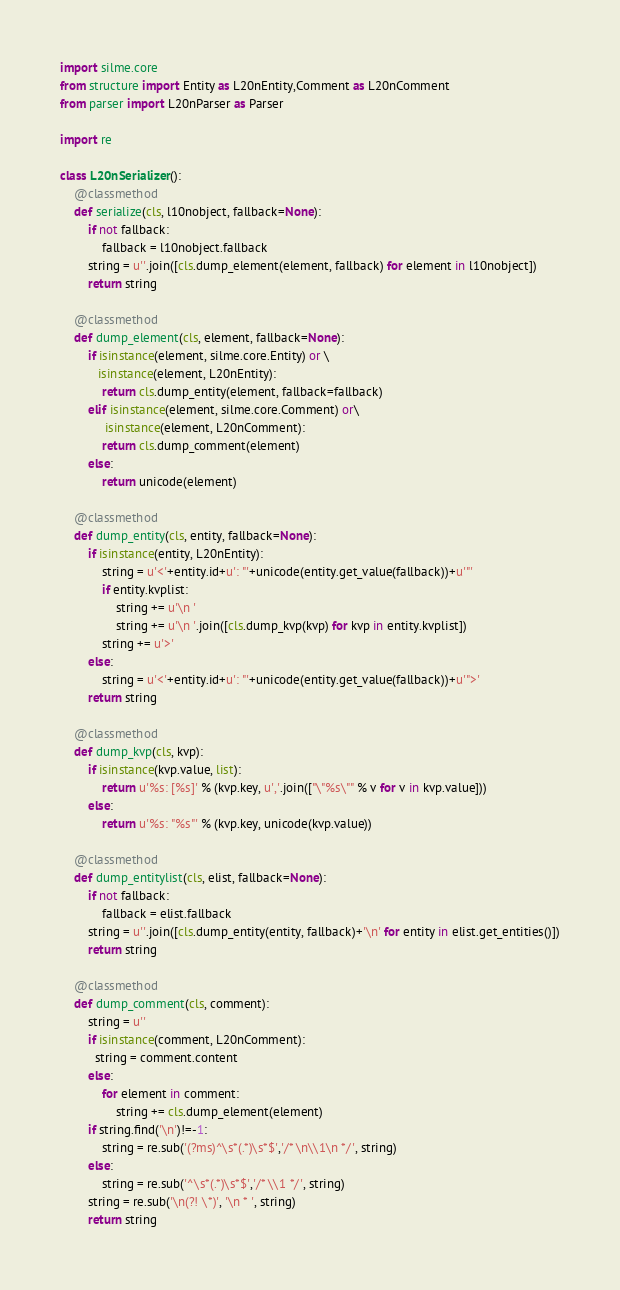<code> <loc_0><loc_0><loc_500><loc_500><_Python_>import silme.core
from structure import Entity as L20nEntity,Comment as L20nComment
from parser import L20nParser as Parser

import re

class L20nSerializer():
    @classmethod
    def serialize(cls, l10nobject, fallback=None):
        if not fallback:
            fallback = l10nobject.fallback
        string = u''.join([cls.dump_element(element, fallback) for element in l10nobject])
        return string

    @classmethod
    def dump_element(cls, element, fallback=None):
        if isinstance(element, silme.core.Entity) or \
           isinstance(element, L20nEntity):
            return cls.dump_entity(element, fallback=fallback)
        elif isinstance(element, silme.core.Comment) or\
             isinstance(element, L20nComment):
            return cls.dump_comment(element)
        else:
            return unicode(element)

    @classmethod
    def dump_entity(cls, entity, fallback=None):
        if isinstance(entity, L20nEntity):
            string = u'<'+entity.id+u': "'+unicode(entity.get_value(fallback))+u'"'
            if entity.kvplist:
                string += u'\n '
                string += u'\n '.join([cls.dump_kvp(kvp) for kvp in entity.kvplist])
            string += u'>'
        else:
            string = u'<'+entity.id+u': "'+unicode(entity.get_value(fallback))+u'">'
        return string

    @classmethod
    def dump_kvp(cls, kvp):
        if isinstance(kvp.value, list):
            return u'%s: [%s]' % (kvp.key, u','.join(["\"%s\"" % v for v in kvp.value]))
        else:
            return u'%s: "%s"' % (kvp.key, unicode(kvp.value))

    @classmethod
    def dump_entitylist(cls, elist, fallback=None):
        if not fallback:
            fallback = elist.fallback
        string = u''.join([cls.dump_entity(entity, fallback)+'\n' for entity in elist.get_entities()])
        return string

    @classmethod
    def dump_comment(cls, comment):
        string = u''
        if isinstance(comment, L20nComment):
          string = comment.content
        else:
            for element in comment:
                string += cls.dump_element(element)
        if string.find('\n')!=-1:
            string = re.sub('(?ms)^\s*(.*)\s*$','/* \n\\1\n */', string)
        else:
            string = re.sub('^\s*(.*)\s*$','/* \\1 */', string)
        string = re.sub('\n(?! \*)', '\n * ', string)
        return string
</code> 